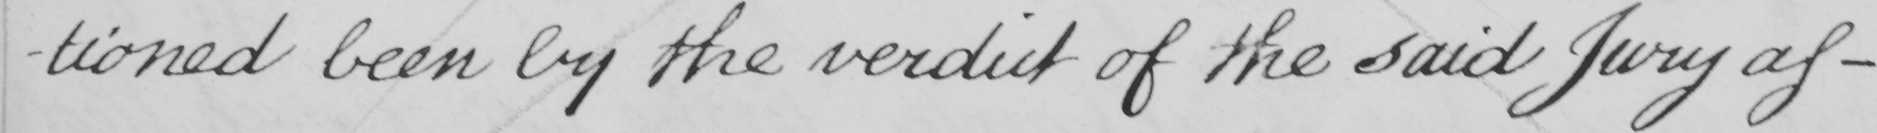Please transcribe the handwritten text in this image. -tioned been by the verdict of the said Jury as- 